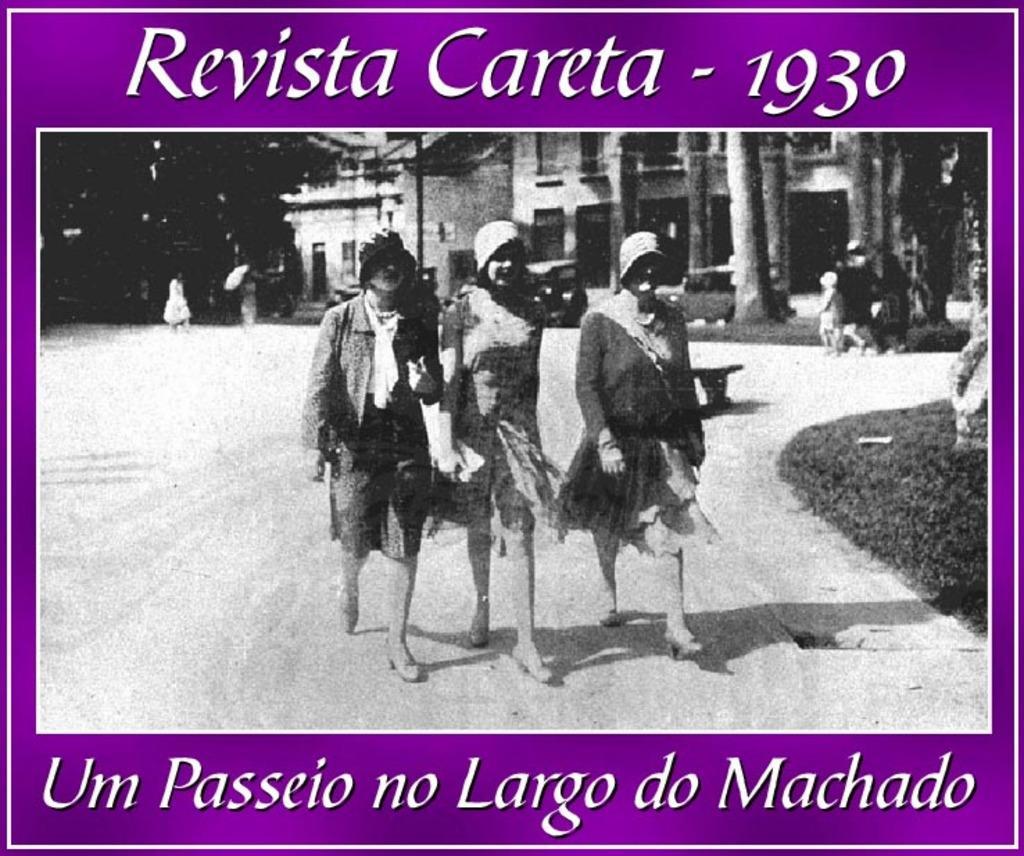Describe this image in one or two sentences. In this image in the center there are persons walking. In the background there are buildings, there are trees and there are persons. On the right side there is grass on the ground and there is some text written on this image. 